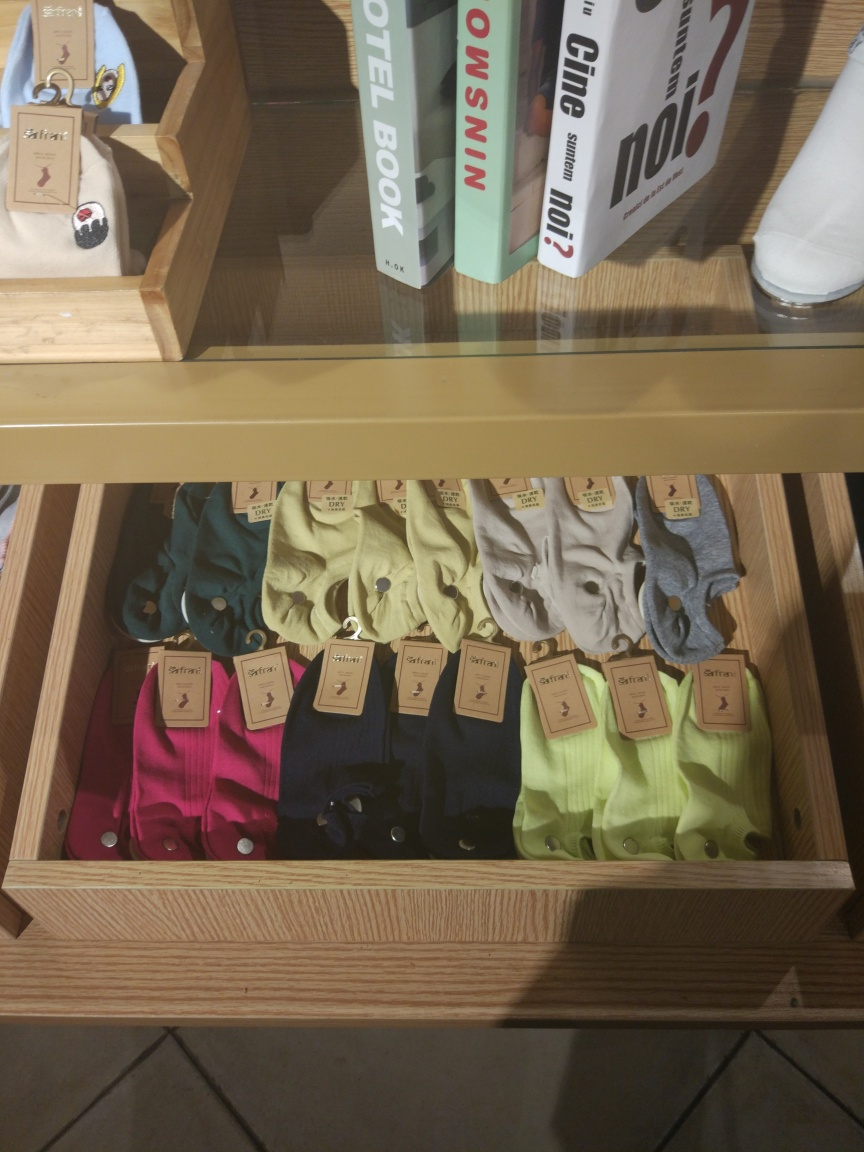Can you describe the potential target market for these products based on the image? Based on the aesthetic and the types of items displayed, the target market may include young to middle-aged adults with an interest in casual yet fashionable attire. The combination of stylish polo shirts and contemporary reading material suggests that the store is likely targeting customers who appreciate modern fashion trends and a cultured lifestyle, possibly with a disposable income to spend on mid to higher-priced items. 